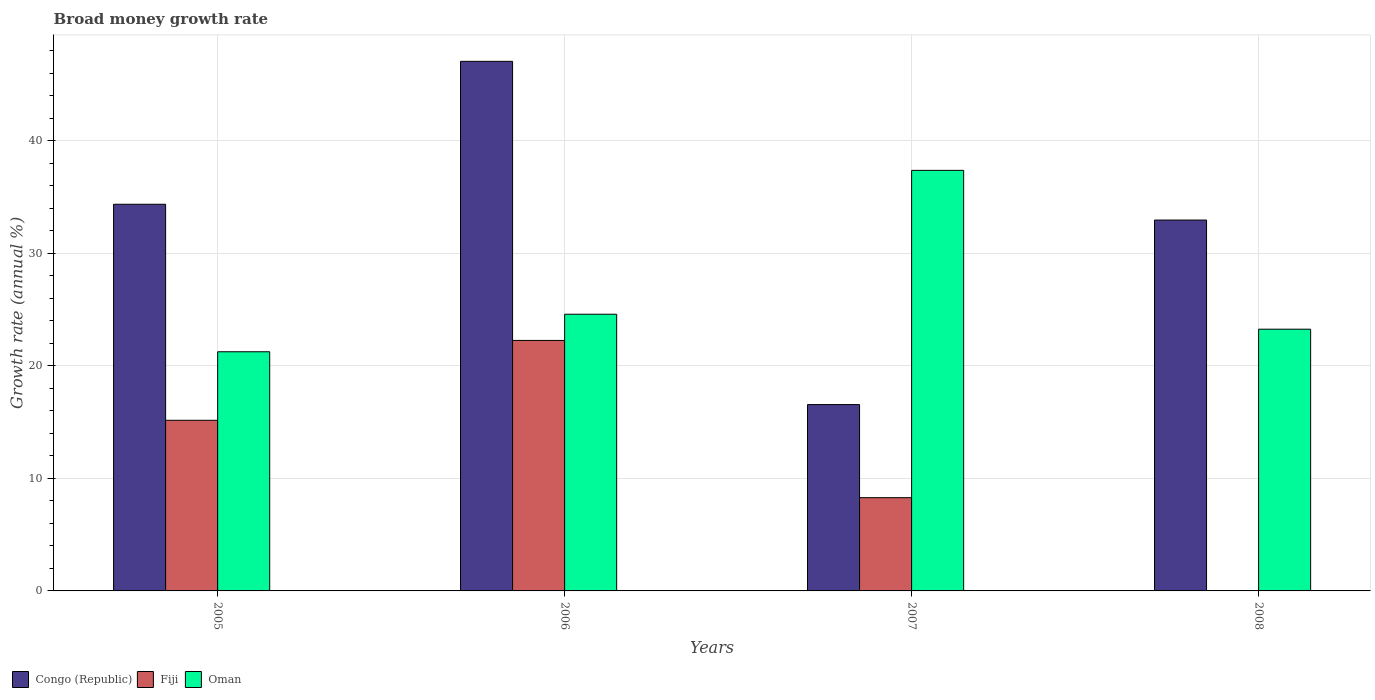How many different coloured bars are there?
Provide a succinct answer. 3. Are the number of bars per tick equal to the number of legend labels?
Offer a terse response. No. What is the growth rate in Oman in 2008?
Your answer should be compact. 23.27. Across all years, what is the maximum growth rate in Fiji?
Your response must be concise. 22.27. Across all years, what is the minimum growth rate in Congo (Republic)?
Offer a very short reply. 16.56. What is the total growth rate in Fiji in the graph?
Your answer should be compact. 45.72. What is the difference between the growth rate in Congo (Republic) in 2005 and that in 2006?
Your response must be concise. -12.7. What is the difference between the growth rate in Oman in 2005 and the growth rate in Fiji in 2006?
Your answer should be very brief. -1.01. What is the average growth rate in Congo (Republic) per year?
Offer a terse response. 32.74. In the year 2008, what is the difference between the growth rate in Oman and growth rate in Congo (Republic)?
Ensure brevity in your answer.  -9.7. What is the ratio of the growth rate in Oman in 2005 to that in 2007?
Your answer should be compact. 0.57. Is the growth rate in Oman in 2006 less than that in 2008?
Your response must be concise. No. What is the difference between the highest and the second highest growth rate in Congo (Republic)?
Keep it short and to the point. 12.7. What is the difference between the highest and the lowest growth rate in Fiji?
Make the answer very short. 22.27. How many bars are there?
Offer a very short reply. 11. Are all the bars in the graph horizontal?
Your answer should be very brief. No. How many years are there in the graph?
Your response must be concise. 4. Does the graph contain any zero values?
Give a very brief answer. Yes. Does the graph contain grids?
Provide a short and direct response. Yes. How are the legend labels stacked?
Provide a short and direct response. Horizontal. What is the title of the graph?
Provide a succinct answer. Broad money growth rate. Does "West Bank and Gaza" appear as one of the legend labels in the graph?
Offer a terse response. No. What is the label or title of the Y-axis?
Provide a short and direct response. Growth rate (annual %). What is the Growth rate (annual %) of Congo (Republic) in 2005?
Offer a terse response. 34.37. What is the Growth rate (annual %) in Fiji in 2005?
Your answer should be very brief. 15.17. What is the Growth rate (annual %) in Oman in 2005?
Give a very brief answer. 21.26. What is the Growth rate (annual %) in Congo (Republic) in 2006?
Provide a succinct answer. 47.08. What is the Growth rate (annual %) in Fiji in 2006?
Your response must be concise. 22.27. What is the Growth rate (annual %) of Oman in 2006?
Provide a short and direct response. 24.6. What is the Growth rate (annual %) in Congo (Republic) in 2007?
Your response must be concise. 16.56. What is the Growth rate (annual %) in Fiji in 2007?
Offer a terse response. 8.29. What is the Growth rate (annual %) in Oman in 2007?
Provide a succinct answer. 37.39. What is the Growth rate (annual %) in Congo (Republic) in 2008?
Provide a succinct answer. 32.97. What is the Growth rate (annual %) of Oman in 2008?
Provide a succinct answer. 23.27. Across all years, what is the maximum Growth rate (annual %) of Congo (Republic)?
Your answer should be very brief. 47.08. Across all years, what is the maximum Growth rate (annual %) of Fiji?
Provide a succinct answer. 22.27. Across all years, what is the maximum Growth rate (annual %) of Oman?
Offer a very short reply. 37.39. Across all years, what is the minimum Growth rate (annual %) in Congo (Republic)?
Give a very brief answer. 16.56. Across all years, what is the minimum Growth rate (annual %) in Fiji?
Keep it short and to the point. 0. Across all years, what is the minimum Growth rate (annual %) in Oman?
Your answer should be very brief. 21.26. What is the total Growth rate (annual %) in Congo (Republic) in the graph?
Your answer should be compact. 130.98. What is the total Growth rate (annual %) of Fiji in the graph?
Your answer should be very brief. 45.72. What is the total Growth rate (annual %) of Oman in the graph?
Your answer should be very brief. 106.51. What is the difference between the Growth rate (annual %) of Congo (Republic) in 2005 and that in 2006?
Ensure brevity in your answer.  -12.7. What is the difference between the Growth rate (annual %) of Fiji in 2005 and that in 2006?
Offer a very short reply. -7.1. What is the difference between the Growth rate (annual %) of Oman in 2005 and that in 2006?
Ensure brevity in your answer.  -3.34. What is the difference between the Growth rate (annual %) in Congo (Republic) in 2005 and that in 2007?
Ensure brevity in your answer.  17.81. What is the difference between the Growth rate (annual %) in Fiji in 2005 and that in 2007?
Offer a terse response. 6.88. What is the difference between the Growth rate (annual %) of Oman in 2005 and that in 2007?
Make the answer very short. -16.13. What is the difference between the Growth rate (annual %) of Congo (Republic) in 2005 and that in 2008?
Offer a very short reply. 1.4. What is the difference between the Growth rate (annual %) in Oman in 2005 and that in 2008?
Offer a terse response. -2.01. What is the difference between the Growth rate (annual %) in Congo (Republic) in 2006 and that in 2007?
Provide a succinct answer. 30.51. What is the difference between the Growth rate (annual %) in Fiji in 2006 and that in 2007?
Offer a terse response. 13.98. What is the difference between the Growth rate (annual %) of Oman in 2006 and that in 2007?
Provide a succinct answer. -12.79. What is the difference between the Growth rate (annual %) in Congo (Republic) in 2006 and that in 2008?
Offer a very short reply. 14.11. What is the difference between the Growth rate (annual %) in Oman in 2006 and that in 2008?
Your answer should be very brief. 1.33. What is the difference between the Growth rate (annual %) in Congo (Republic) in 2007 and that in 2008?
Make the answer very short. -16.4. What is the difference between the Growth rate (annual %) of Oman in 2007 and that in 2008?
Ensure brevity in your answer.  14.12. What is the difference between the Growth rate (annual %) in Congo (Republic) in 2005 and the Growth rate (annual %) in Fiji in 2006?
Your answer should be compact. 12.1. What is the difference between the Growth rate (annual %) of Congo (Republic) in 2005 and the Growth rate (annual %) of Oman in 2006?
Give a very brief answer. 9.78. What is the difference between the Growth rate (annual %) of Fiji in 2005 and the Growth rate (annual %) of Oman in 2006?
Give a very brief answer. -9.43. What is the difference between the Growth rate (annual %) of Congo (Republic) in 2005 and the Growth rate (annual %) of Fiji in 2007?
Offer a very short reply. 26.08. What is the difference between the Growth rate (annual %) of Congo (Republic) in 2005 and the Growth rate (annual %) of Oman in 2007?
Provide a short and direct response. -3.01. What is the difference between the Growth rate (annual %) in Fiji in 2005 and the Growth rate (annual %) in Oman in 2007?
Your answer should be compact. -22.22. What is the difference between the Growth rate (annual %) of Congo (Republic) in 2005 and the Growth rate (annual %) of Oman in 2008?
Offer a very short reply. 11.11. What is the difference between the Growth rate (annual %) in Fiji in 2005 and the Growth rate (annual %) in Oman in 2008?
Your response must be concise. -8.1. What is the difference between the Growth rate (annual %) in Congo (Republic) in 2006 and the Growth rate (annual %) in Fiji in 2007?
Give a very brief answer. 38.79. What is the difference between the Growth rate (annual %) of Congo (Republic) in 2006 and the Growth rate (annual %) of Oman in 2007?
Provide a succinct answer. 9.69. What is the difference between the Growth rate (annual %) of Fiji in 2006 and the Growth rate (annual %) of Oman in 2007?
Provide a succinct answer. -15.12. What is the difference between the Growth rate (annual %) of Congo (Republic) in 2006 and the Growth rate (annual %) of Oman in 2008?
Offer a very short reply. 23.81. What is the difference between the Growth rate (annual %) in Fiji in 2006 and the Growth rate (annual %) in Oman in 2008?
Make the answer very short. -1. What is the difference between the Growth rate (annual %) in Congo (Republic) in 2007 and the Growth rate (annual %) in Oman in 2008?
Make the answer very short. -6.7. What is the difference between the Growth rate (annual %) of Fiji in 2007 and the Growth rate (annual %) of Oman in 2008?
Provide a short and direct response. -14.98. What is the average Growth rate (annual %) of Congo (Republic) per year?
Offer a very short reply. 32.74. What is the average Growth rate (annual %) of Fiji per year?
Give a very brief answer. 11.43. What is the average Growth rate (annual %) in Oman per year?
Your response must be concise. 26.63. In the year 2005, what is the difference between the Growth rate (annual %) in Congo (Republic) and Growth rate (annual %) in Fiji?
Make the answer very short. 19.2. In the year 2005, what is the difference between the Growth rate (annual %) of Congo (Republic) and Growth rate (annual %) of Oman?
Ensure brevity in your answer.  13.11. In the year 2005, what is the difference between the Growth rate (annual %) of Fiji and Growth rate (annual %) of Oman?
Provide a succinct answer. -6.09. In the year 2006, what is the difference between the Growth rate (annual %) of Congo (Republic) and Growth rate (annual %) of Fiji?
Ensure brevity in your answer.  24.81. In the year 2006, what is the difference between the Growth rate (annual %) of Congo (Republic) and Growth rate (annual %) of Oman?
Provide a succinct answer. 22.48. In the year 2006, what is the difference between the Growth rate (annual %) of Fiji and Growth rate (annual %) of Oman?
Offer a very short reply. -2.33. In the year 2007, what is the difference between the Growth rate (annual %) of Congo (Republic) and Growth rate (annual %) of Fiji?
Offer a terse response. 8.28. In the year 2007, what is the difference between the Growth rate (annual %) of Congo (Republic) and Growth rate (annual %) of Oman?
Give a very brief answer. -20.82. In the year 2007, what is the difference between the Growth rate (annual %) in Fiji and Growth rate (annual %) in Oman?
Your response must be concise. -29.1. In the year 2008, what is the difference between the Growth rate (annual %) of Congo (Republic) and Growth rate (annual %) of Oman?
Your answer should be compact. 9.7. What is the ratio of the Growth rate (annual %) in Congo (Republic) in 2005 to that in 2006?
Keep it short and to the point. 0.73. What is the ratio of the Growth rate (annual %) of Fiji in 2005 to that in 2006?
Give a very brief answer. 0.68. What is the ratio of the Growth rate (annual %) of Oman in 2005 to that in 2006?
Your answer should be very brief. 0.86. What is the ratio of the Growth rate (annual %) in Congo (Republic) in 2005 to that in 2007?
Your answer should be very brief. 2.08. What is the ratio of the Growth rate (annual %) of Fiji in 2005 to that in 2007?
Provide a short and direct response. 1.83. What is the ratio of the Growth rate (annual %) in Oman in 2005 to that in 2007?
Your answer should be compact. 0.57. What is the ratio of the Growth rate (annual %) of Congo (Republic) in 2005 to that in 2008?
Provide a short and direct response. 1.04. What is the ratio of the Growth rate (annual %) of Oman in 2005 to that in 2008?
Your response must be concise. 0.91. What is the ratio of the Growth rate (annual %) in Congo (Republic) in 2006 to that in 2007?
Your answer should be very brief. 2.84. What is the ratio of the Growth rate (annual %) in Fiji in 2006 to that in 2007?
Your answer should be very brief. 2.69. What is the ratio of the Growth rate (annual %) of Oman in 2006 to that in 2007?
Your answer should be very brief. 0.66. What is the ratio of the Growth rate (annual %) in Congo (Republic) in 2006 to that in 2008?
Offer a very short reply. 1.43. What is the ratio of the Growth rate (annual %) of Oman in 2006 to that in 2008?
Provide a short and direct response. 1.06. What is the ratio of the Growth rate (annual %) of Congo (Republic) in 2007 to that in 2008?
Give a very brief answer. 0.5. What is the ratio of the Growth rate (annual %) of Oman in 2007 to that in 2008?
Offer a very short reply. 1.61. What is the difference between the highest and the second highest Growth rate (annual %) of Congo (Republic)?
Give a very brief answer. 12.7. What is the difference between the highest and the second highest Growth rate (annual %) in Oman?
Your answer should be compact. 12.79. What is the difference between the highest and the lowest Growth rate (annual %) in Congo (Republic)?
Offer a very short reply. 30.51. What is the difference between the highest and the lowest Growth rate (annual %) of Fiji?
Provide a short and direct response. 22.27. What is the difference between the highest and the lowest Growth rate (annual %) of Oman?
Give a very brief answer. 16.13. 